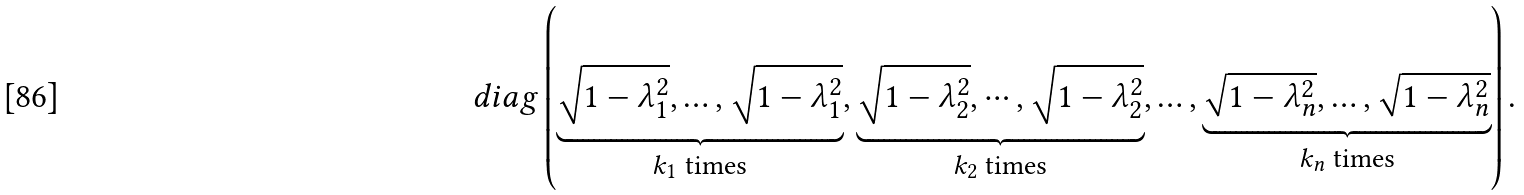Convert formula to latex. <formula><loc_0><loc_0><loc_500><loc_500>d i a g \left ( \underbrace { \sqrt { 1 - \lambda _ { 1 } ^ { 2 } } , \dots , \sqrt { 1 - \lambda _ { 1 } ^ { 2 } } } _ { \text {$k_{1}$ times} } , \underbrace { \sqrt { 1 - \lambda _ { 2 } ^ { 2 } } , \cdots , \sqrt { 1 - \lambda _ { 2 } ^ { 2 } } } _ { \text {$k_{2}$ times} } , \dots , \underbrace { \sqrt { 1 - \lambda _ { n } ^ { 2 } } , \dots , \sqrt { 1 - \lambda _ { n } ^ { 2 } } } _ { \text {$k_{n}$ times} } \right ) .</formula> 